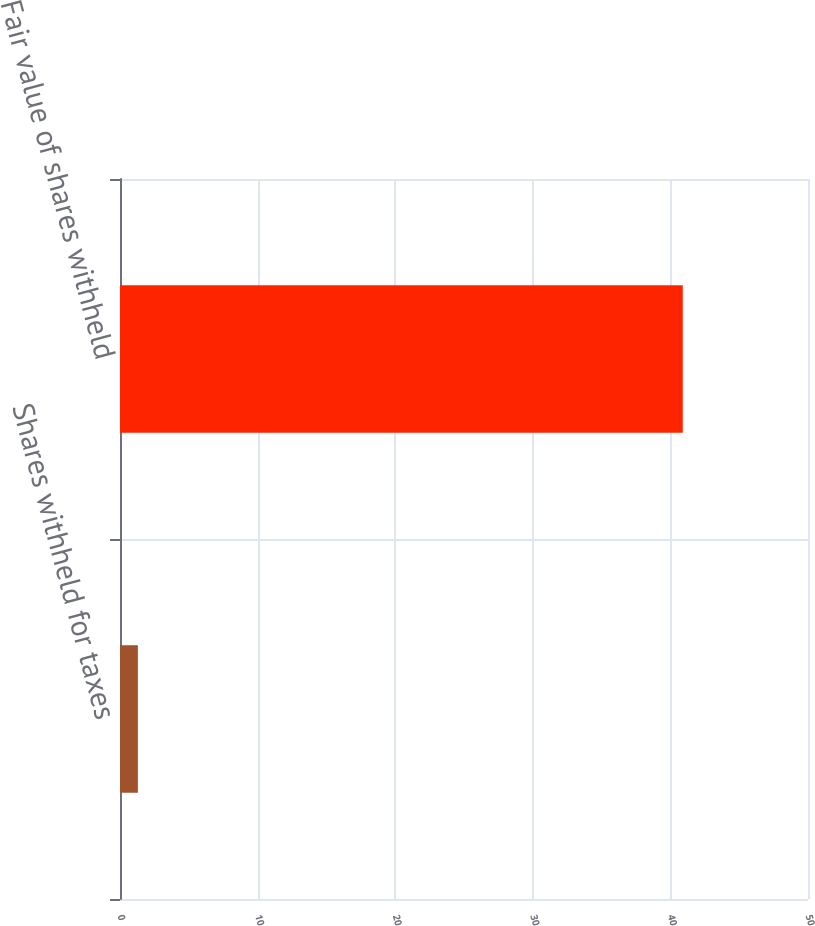Convert chart to OTSL. <chart><loc_0><loc_0><loc_500><loc_500><bar_chart><fcel>Shares withheld for taxes<fcel>Fair value of shares withheld<nl><fcel>1.3<fcel>40.9<nl></chart> 